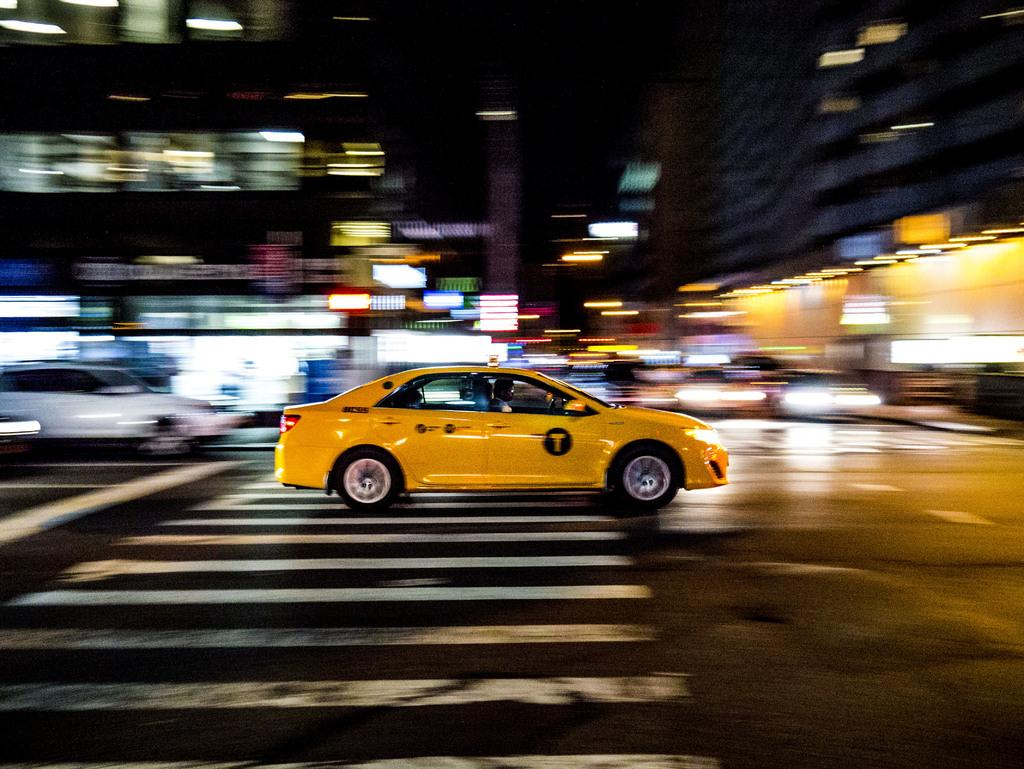Provide a one-sentence caption for the provided image. A yellow taxi with a large yellow capital T in a black circle races over a crosswalk on a city street with a blurred background. 